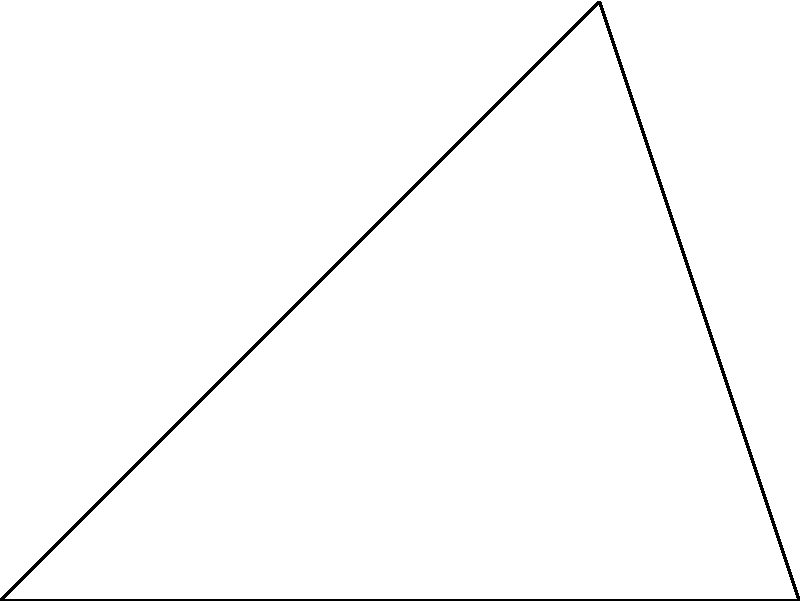You're tasked with intercepting an enemy aircraft. Your fighter jet (at point O) can fly at $v_i = 1200$ km/h, while the target aircraft (currently at point A) is flying at $v_t = 1000$ km/h towards point B. The angle between OA and AB is $60^\circ$, and the distance OA is 80 km. Calculate the optimal intercept angle $\theta$ (angle BOA) to successfully intercept the target before it reaches point B. To solve this problem, we'll use the law of sines and iterative calculations:

1) First, we need to find the time it takes for the target to reach point B:
   $t_B = \frac{OA \cdot \sin(60^\circ)}{v_t} = \frac{80 \cdot \sin(60^\circ)}{1000} = 0.0693$ hours

2) Now, we'll use an iterative process to find the angle $\theta$ that allows interception at exactly $t_B$:

   a) Start with an initial guess for $\theta$, say $30^\circ$
   b) Calculate the distance OB: $OB = \frac{OA \cdot \sin(60^\circ)}{\sin(180^\circ - 60^\circ - \theta)}$
   c) Calculate the time to reach B: $t_i = \frac{OB}{v_i}$
   d) If $t_i < t_B$, increase $\theta$; if $t_i > t_B$, decrease $\theta$
   e) Repeat until $t_i \approx t_B$

3) After iteration, we find that $\theta \approx 41.8^\circ$ gives $t_i \approx t_B = 0.0693$ hours

4) Verify:
   $OB = \frac{80 \cdot \sin(60^\circ)}{\sin(180^\circ - 60^\circ - 41.8^\circ)} = 83.16$ km
   $t_i = \frac{83.16}{1200} = 0.0693$ hours

Therefore, the optimal intercept angle is approximately $41.8^\circ$.
Answer: $41.8^\circ$ 